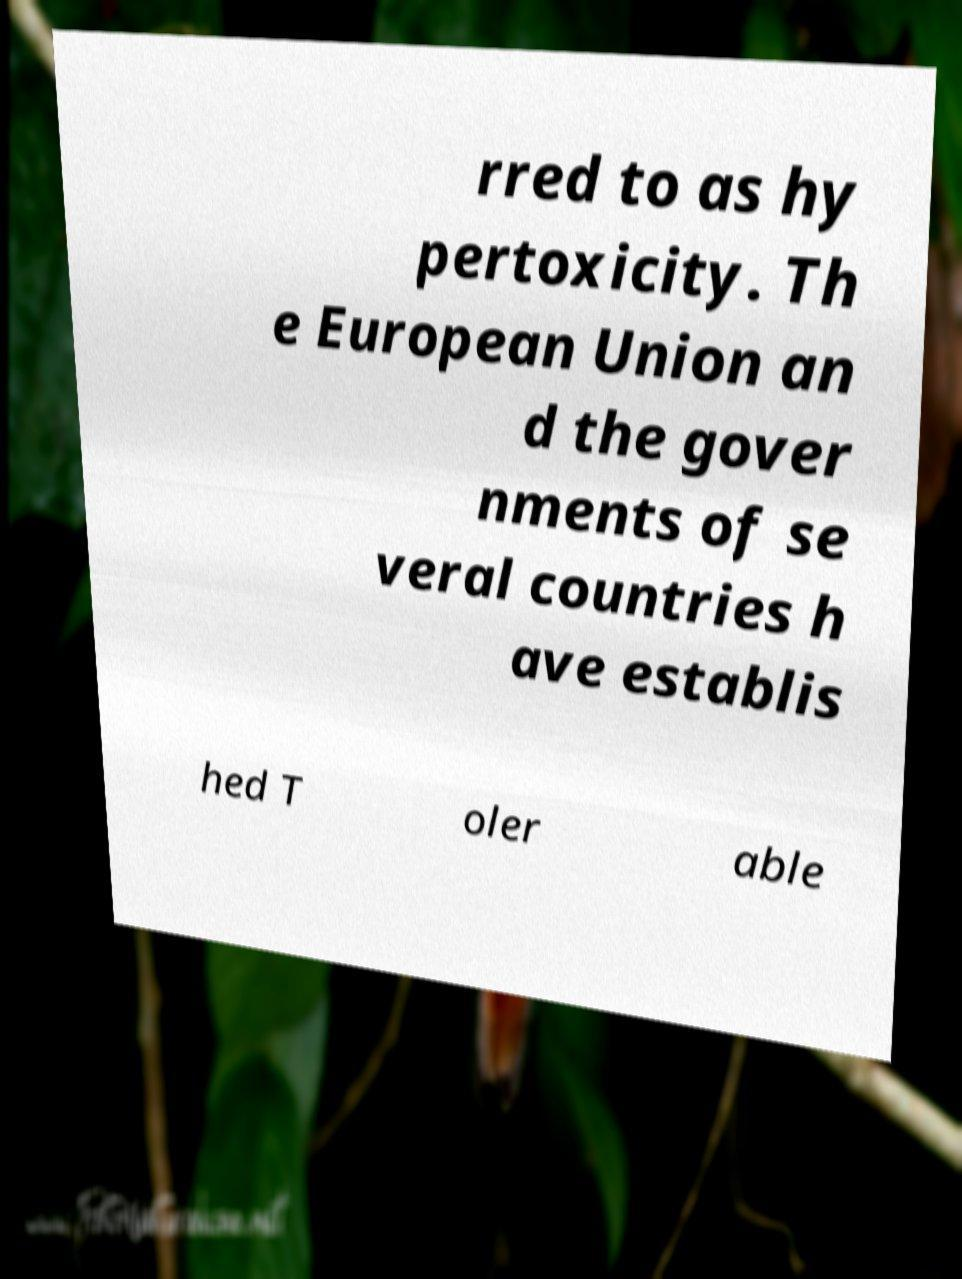Please read and relay the text visible in this image. What does it say? rred to as hy pertoxicity. Th e European Union an d the gover nments of se veral countries h ave establis hed T oler able 